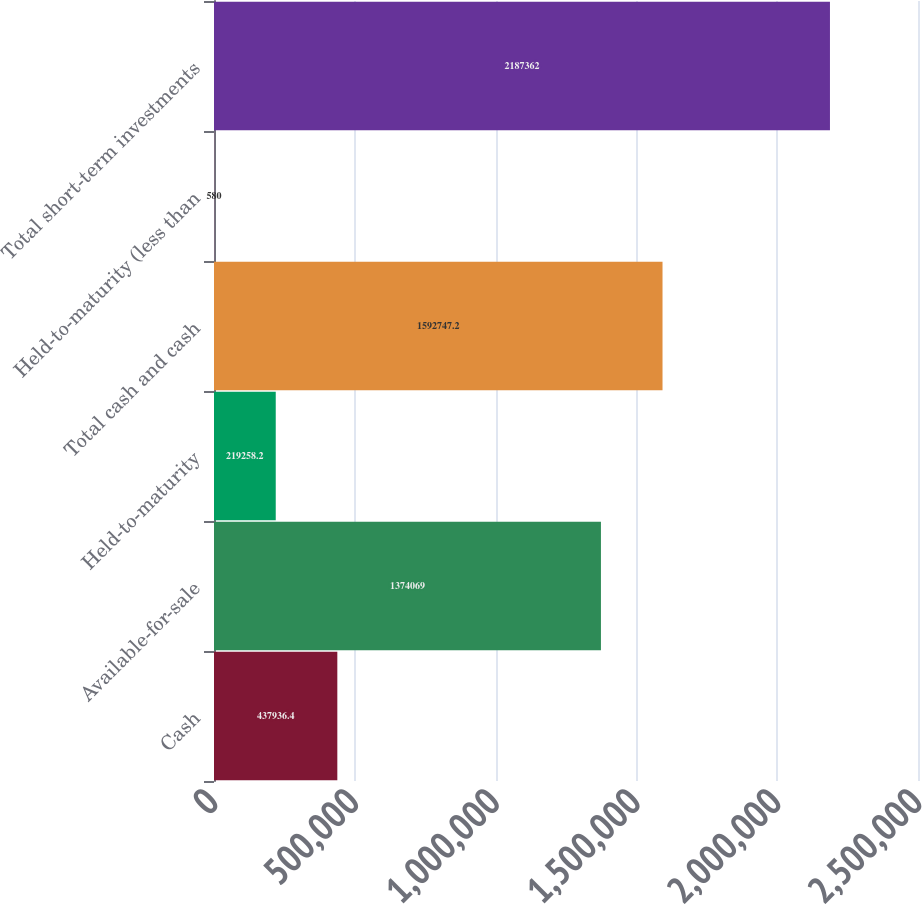<chart> <loc_0><loc_0><loc_500><loc_500><bar_chart><fcel>Cash<fcel>Available-for-sale<fcel>Held-to-maturity<fcel>Total cash and cash<fcel>Held-to-maturity (less than<fcel>Total short-term investments<nl><fcel>437936<fcel>1.37407e+06<fcel>219258<fcel>1.59275e+06<fcel>580<fcel>2.18736e+06<nl></chart> 